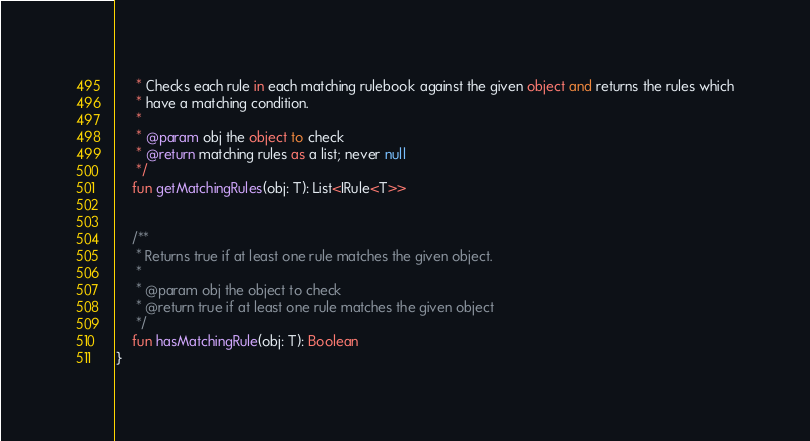Convert code to text. <code><loc_0><loc_0><loc_500><loc_500><_Kotlin_>     * Checks each rule in each matching rulebook against the given object and returns the rules which
     * have a matching condition.
     *
     * @param obj the object to check
     * @return matching rules as a list; never null
     */
    fun getMatchingRules(obj: T): List<IRule<T>>


    /**
     * Returns true if at least one rule matches the given object.
     *
     * @param obj the object to check
     * @return true if at least one rule matches the given object
     */
    fun hasMatchingRule(obj: T): Boolean
}</code> 